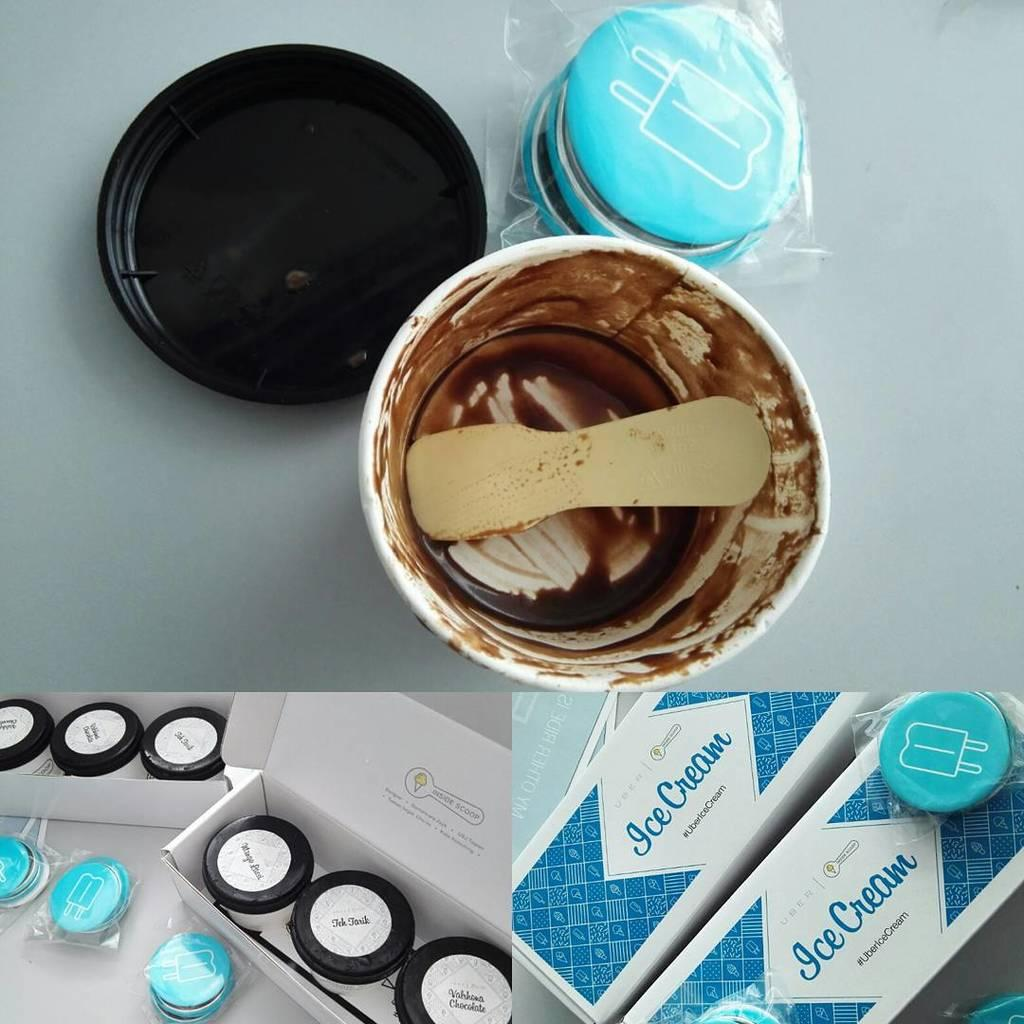<image>
Provide a brief description of the given image. An eaten tub of ice cream on top of images of the ice cream packaging. 